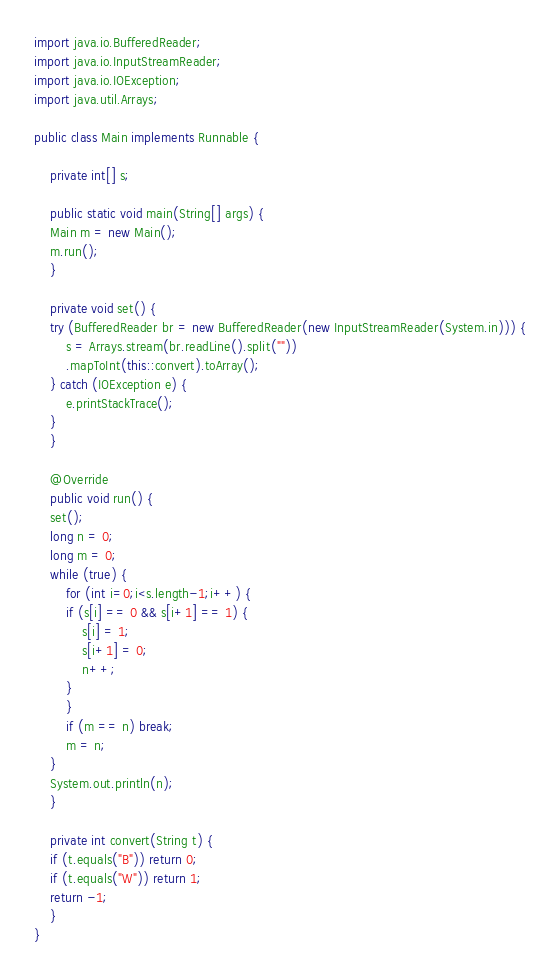<code> <loc_0><loc_0><loc_500><loc_500><_Java_>import java.io.BufferedReader;
import java.io.InputStreamReader;
import java.io.IOException;
import java.util.Arrays;

public class Main implements Runnable {

    private int[] s;
    
    public static void main(String[] args) {
	Main m = new Main();
	m.run();
    }

    private void set() {
	try (BufferedReader br = new BufferedReader(new InputStreamReader(System.in))) {
	    s = Arrays.stream(br.readLine().split(""))
		.mapToInt(this::convert).toArray();
	} catch (IOException e) {
	    e.printStackTrace();
	}
    }

    @Override
    public void run() {
	set();
	long n = 0;
	long m = 0;
	while (true) {
	    for (int i=0;i<s.length-1;i++) {
		if (s[i] == 0 && s[i+1] == 1) {
		    s[i] = 1;
		    s[i+1] = 0;
		    n++;
		}
	    }
	    if (m == n) break;
	    m = n;
	}
	System.out.println(n);
    }

    private int convert(String t) {
	if (t.equals("B")) return 0;
	if (t.equals("W")) return 1;
	return -1;
    }
}</code> 